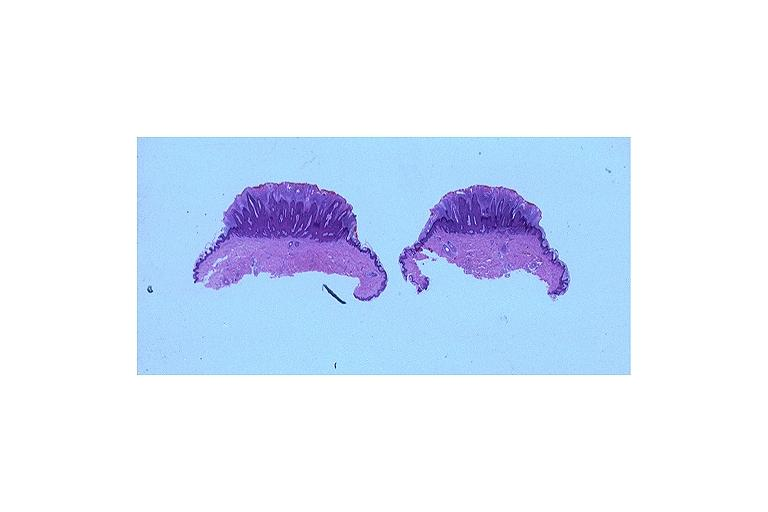what is present?
Answer the question using a single word or phrase. Oral 